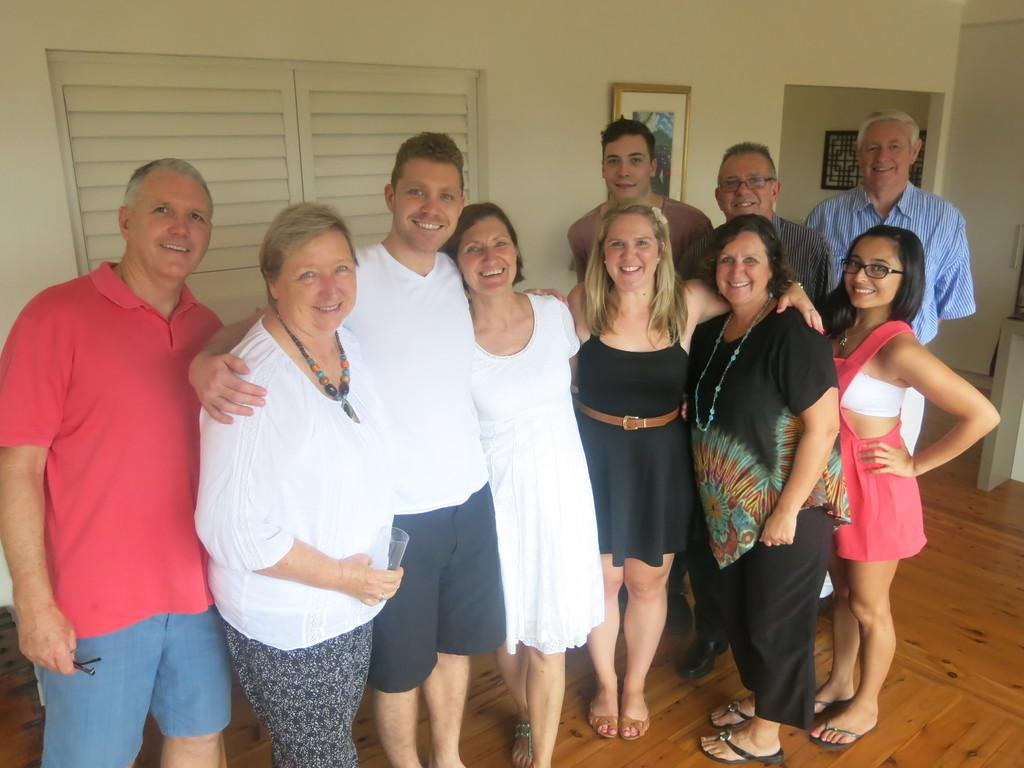How many persons are in the image? There are persons in the image. What can be observed about the dresses worn by the persons? The persons are wearing different color dresses. What is the facial expression of the persons in the image? The persons are smiling. Where are the persons standing in the image? The persons are standing on a floor. What is present in the background of the image? There is a photo frame in the background of the image, and it is attached to a wall. What else can be seen in the background of the image? There is a window visible in the background of the image. What type of government is depicted in the image? There is no depiction of a government in the image; it features persons wearing different color dresses and smiling. What color is the sweater worn by the person in the image? There is no sweater present in the image; the persons are wearing dresses. 